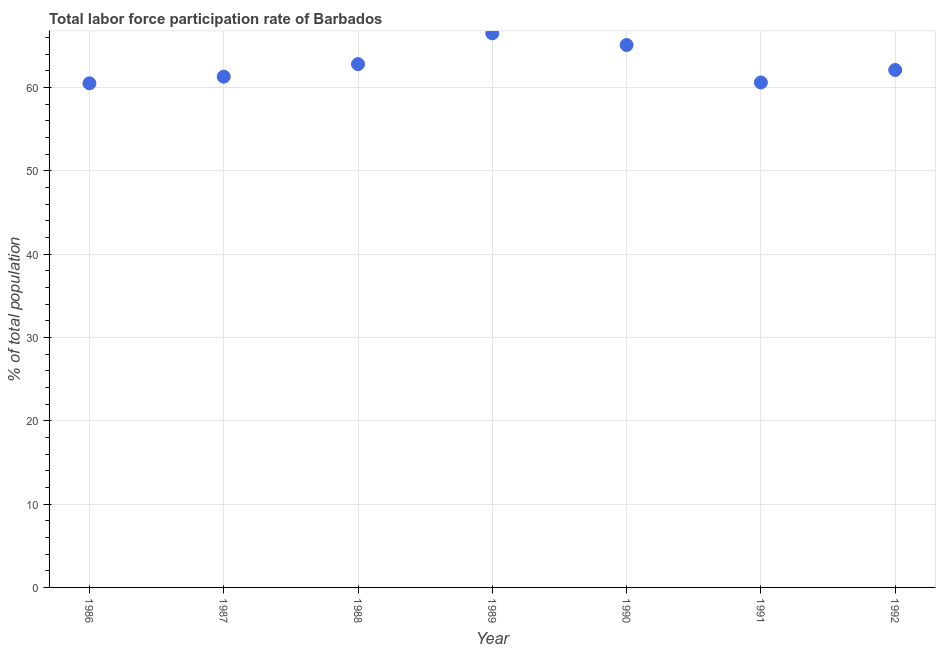What is the total labor force participation rate in 1987?
Ensure brevity in your answer.  61.3. Across all years, what is the maximum total labor force participation rate?
Provide a short and direct response. 66.5. Across all years, what is the minimum total labor force participation rate?
Keep it short and to the point. 60.5. What is the sum of the total labor force participation rate?
Offer a terse response. 438.9. What is the difference between the total labor force participation rate in 1989 and 1990?
Offer a terse response. 1.4. What is the average total labor force participation rate per year?
Provide a succinct answer. 62.7. What is the median total labor force participation rate?
Your answer should be compact. 62.1. Do a majority of the years between 1991 and 1988 (inclusive) have total labor force participation rate greater than 56 %?
Give a very brief answer. Yes. What is the ratio of the total labor force participation rate in 1987 to that in 1988?
Offer a terse response. 0.98. What is the difference between the highest and the second highest total labor force participation rate?
Offer a very short reply. 1.4. In how many years, is the total labor force participation rate greater than the average total labor force participation rate taken over all years?
Offer a very short reply. 3. Does the total labor force participation rate monotonically increase over the years?
Your answer should be very brief. No. What is the difference between two consecutive major ticks on the Y-axis?
Offer a very short reply. 10. Does the graph contain grids?
Your answer should be compact. Yes. What is the title of the graph?
Offer a terse response. Total labor force participation rate of Barbados. What is the label or title of the X-axis?
Your response must be concise. Year. What is the label or title of the Y-axis?
Provide a short and direct response. % of total population. What is the % of total population in 1986?
Ensure brevity in your answer.  60.5. What is the % of total population in 1987?
Your response must be concise. 61.3. What is the % of total population in 1988?
Make the answer very short. 62.8. What is the % of total population in 1989?
Provide a succinct answer. 66.5. What is the % of total population in 1990?
Your answer should be very brief. 65.1. What is the % of total population in 1991?
Make the answer very short. 60.6. What is the % of total population in 1992?
Provide a succinct answer. 62.1. What is the difference between the % of total population in 1986 and 1989?
Give a very brief answer. -6. What is the difference between the % of total population in 1986 and 1990?
Offer a terse response. -4.6. What is the difference between the % of total population in 1987 and 1988?
Give a very brief answer. -1.5. What is the difference between the % of total population in 1987 and 1989?
Provide a short and direct response. -5.2. What is the difference between the % of total population in 1987 and 1990?
Offer a terse response. -3.8. What is the difference between the % of total population in 1988 and 1990?
Your answer should be very brief. -2.3. What is the difference between the % of total population in 1988 and 1991?
Offer a very short reply. 2.2. What is the difference between the % of total population in 1988 and 1992?
Provide a succinct answer. 0.7. What is the difference between the % of total population in 1989 and 1990?
Provide a short and direct response. 1.4. What is the difference between the % of total population in 1989 and 1992?
Provide a succinct answer. 4.4. What is the difference between the % of total population in 1991 and 1992?
Give a very brief answer. -1.5. What is the ratio of the % of total population in 1986 to that in 1989?
Provide a short and direct response. 0.91. What is the ratio of the % of total population in 1986 to that in 1990?
Make the answer very short. 0.93. What is the ratio of the % of total population in 1986 to that in 1991?
Your answer should be compact. 1. What is the ratio of the % of total population in 1987 to that in 1988?
Your answer should be compact. 0.98. What is the ratio of the % of total population in 1987 to that in 1989?
Offer a terse response. 0.92. What is the ratio of the % of total population in 1987 to that in 1990?
Provide a short and direct response. 0.94. What is the ratio of the % of total population in 1987 to that in 1992?
Ensure brevity in your answer.  0.99. What is the ratio of the % of total population in 1988 to that in 1989?
Your answer should be compact. 0.94. What is the ratio of the % of total population in 1988 to that in 1990?
Ensure brevity in your answer.  0.96. What is the ratio of the % of total population in 1988 to that in 1991?
Your answer should be compact. 1.04. What is the ratio of the % of total population in 1989 to that in 1991?
Ensure brevity in your answer.  1.1. What is the ratio of the % of total population in 1989 to that in 1992?
Give a very brief answer. 1.07. What is the ratio of the % of total population in 1990 to that in 1991?
Your answer should be compact. 1.07. What is the ratio of the % of total population in 1990 to that in 1992?
Offer a terse response. 1.05. 